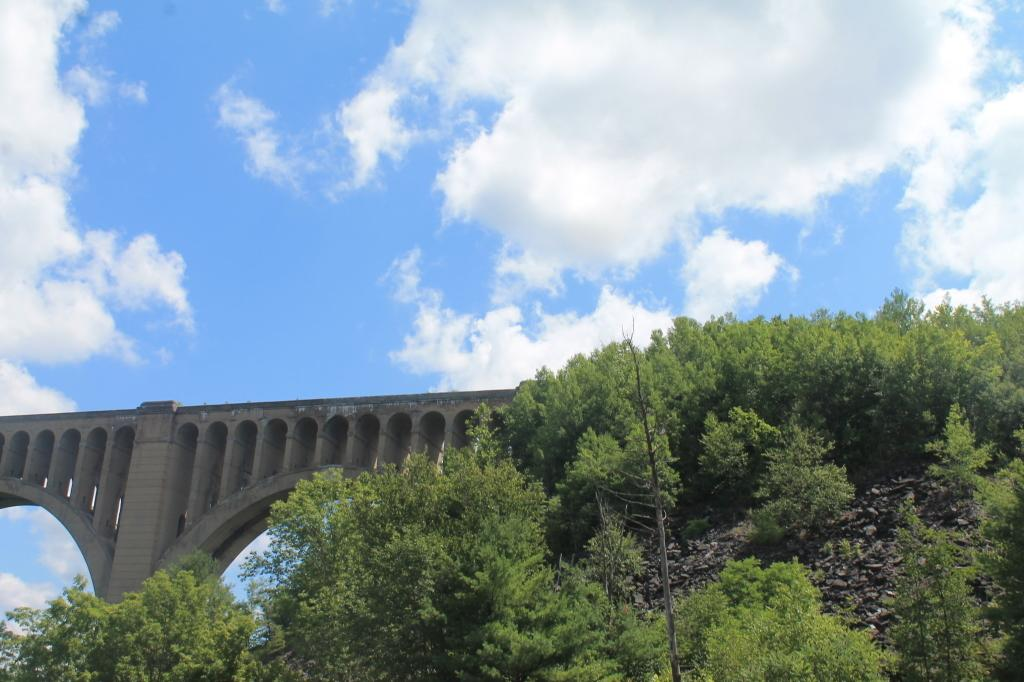What type of natural elements can be seen in the image? There are trees in the image. What structure is visible behind the trees? There is a bridge behind the trees in the image. What type of downtown design is visible in the image? There is no downtown design present in the image; it features trees and a bridge. What type of railway system can be seen in the image? There is no railway system present in the image. 